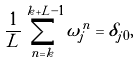<formula> <loc_0><loc_0><loc_500><loc_500>\frac { 1 } { L } \sum _ { n = k } ^ { k + L - 1 } \omega _ { j } ^ { n } = \delta _ { j 0 } ,</formula> 